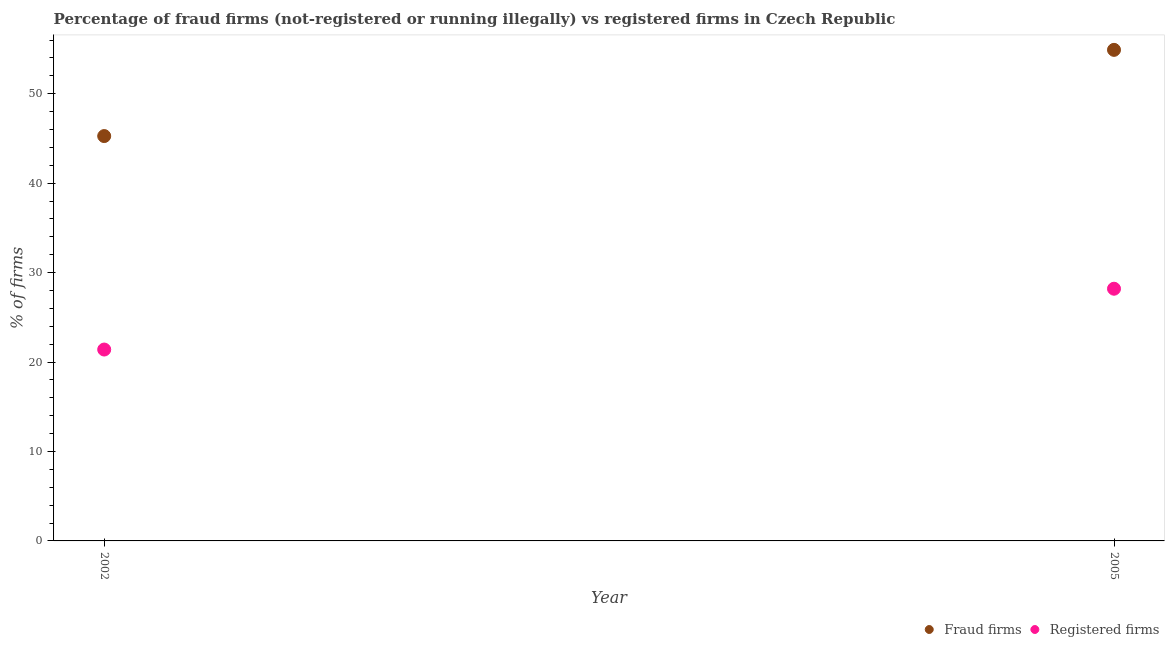How many different coloured dotlines are there?
Your answer should be very brief. 2. Is the number of dotlines equal to the number of legend labels?
Your answer should be very brief. Yes. What is the percentage of registered firms in 2005?
Ensure brevity in your answer.  28.2. Across all years, what is the maximum percentage of fraud firms?
Your answer should be very brief. 54.91. Across all years, what is the minimum percentage of fraud firms?
Provide a short and direct response. 45.27. In which year was the percentage of registered firms maximum?
Give a very brief answer. 2005. What is the total percentage of registered firms in the graph?
Your answer should be compact. 49.6. What is the difference between the percentage of registered firms in 2002 and that in 2005?
Provide a short and direct response. -6.8. What is the difference between the percentage of registered firms in 2002 and the percentage of fraud firms in 2005?
Offer a terse response. -33.51. What is the average percentage of registered firms per year?
Make the answer very short. 24.8. In the year 2002, what is the difference between the percentage of registered firms and percentage of fraud firms?
Give a very brief answer. -23.87. In how many years, is the percentage of fraud firms greater than 48 %?
Provide a succinct answer. 1. What is the ratio of the percentage of fraud firms in 2002 to that in 2005?
Offer a very short reply. 0.82. Is the percentage of registered firms in 2002 less than that in 2005?
Make the answer very short. Yes. In how many years, is the percentage of fraud firms greater than the average percentage of fraud firms taken over all years?
Offer a very short reply. 1. Does the percentage of fraud firms monotonically increase over the years?
Make the answer very short. Yes. Is the percentage of fraud firms strictly less than the percentage of registered firms over the years?
Offer a very short reply. No. How many dotlines are there?
Your response must be concise. 2. How many years are there in the graph?
Keep it short and to the point. 2. What is the difference between two consecutive major ticks on the Y-axis?
Provide a short and direct response. 10. Are the values on the major ticks of Y-axis written in scientific E-notation?
Offer a terse response. No. How many legend labels are there?
Ensure brevity in your answer.  2. How are the legend labels stacked?
Ensure brevity in your answer.  Horizontal. What is the title of the graph?
Give a very brief answer. Percentage of fraud firms (not-registered or running illegally) vs registered firms in Czech Republic. Does "Not attending school" appear as one of the legend labels in the graph?
Your response must be concise. No. What is the label or title of the Y-axis?
Offer a terse response. % of firms. What is the % of firms in Fraud firms in 2002?
Give a very brief answer. 45.27. What is the % of firms in Registered firms in 2002?
Offer a terse response. 21.4. What is the % of firms in Fraud firms in 2005?
Give a very brief answer. 54.91. What is the % of firms of Registered firms in 2005?
Provide a succinct answer. 28.2. Across all years, what is the maximum % of firms of Fraud firms?
Make the answer very short. 54.91. Across all years, what is the maximum % of firms of Registered firms?
Give a very brief answer. 28.2. Across all years, what is the minimum % of firms of Fraud firms?
Make the answer very short. 45.27. Across all years, what is the minimum % of firms in Registered firms?
Ensure brevity in your answer.  21.4. What is the total % of firms of Fraud firms in the graph?
Your answer should be compact. 100.18. What is the total % of firms in Registered firms in the graph?
Offer a very short reply. 49.6. What is the difference between the % of firms in Fraud firms in 2002 and that in 2005?
Keep it short and to the point. -9.64. What is the difference between the % of firms in Fraud firms in 2002 and the % of firms in Registered firms in 2005?
Provide a succinct answer. 17.07. What is the average % of firms of Fraud firms per year?
Your answer should be compact. 50.09. What is the average % of firms of Registered firms per year?
Your answer should be very brief. 24.8. In the year 2002, what is the difference between the % of firms in Fraud firms and % of firms in Registered firms?
Provide a short and direct response. 23.87. In the year 2005, what is the difference between the % of firms of Fraud firms and % of firms of Registered firms?
Your answer should be compact. 26.71. What is the ratio of the % of firms in Fraud firms in 2002 to that in 2005?
Provide a short and direct response. 0.82. What is the ratio of the % of firms of Registered firms in 2002 to that in 2005?
Provide a short and direct response. 0.76. What is the difference between the highest and the second highest % of firms in Fraud firms?
Offer a very short reply. 9.64. What is the difference between the highest and the lowest % of firms of Fraud firms?
Your answer should be very brief. 9.64. What is the difference between the highest and the lowest % of firms in Registered firms?
Provide a succinct answer. 6.8. 